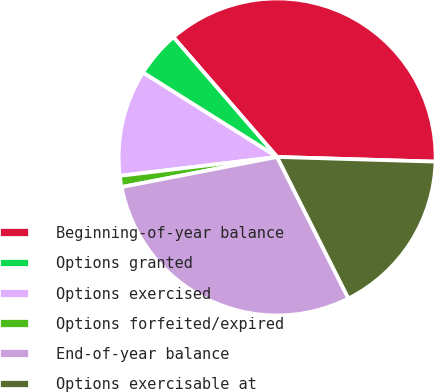Convert chart to OTSL. <chart><loc_0><loc_0><loc_500><loc_500><pie_chart><fcel>Beginning-of-year balance<fcel>Options granted<fcel>Options exercised<fcel>Options forfeited/expired<fcel>End-of-year balance<fcel>Options exercisable at<nl><fcel>36.83%<fcel>4.71%<fcel>10.84%<fcel>1.14%<fcel>29.39%<fcel>17.1%<nl></chart> 